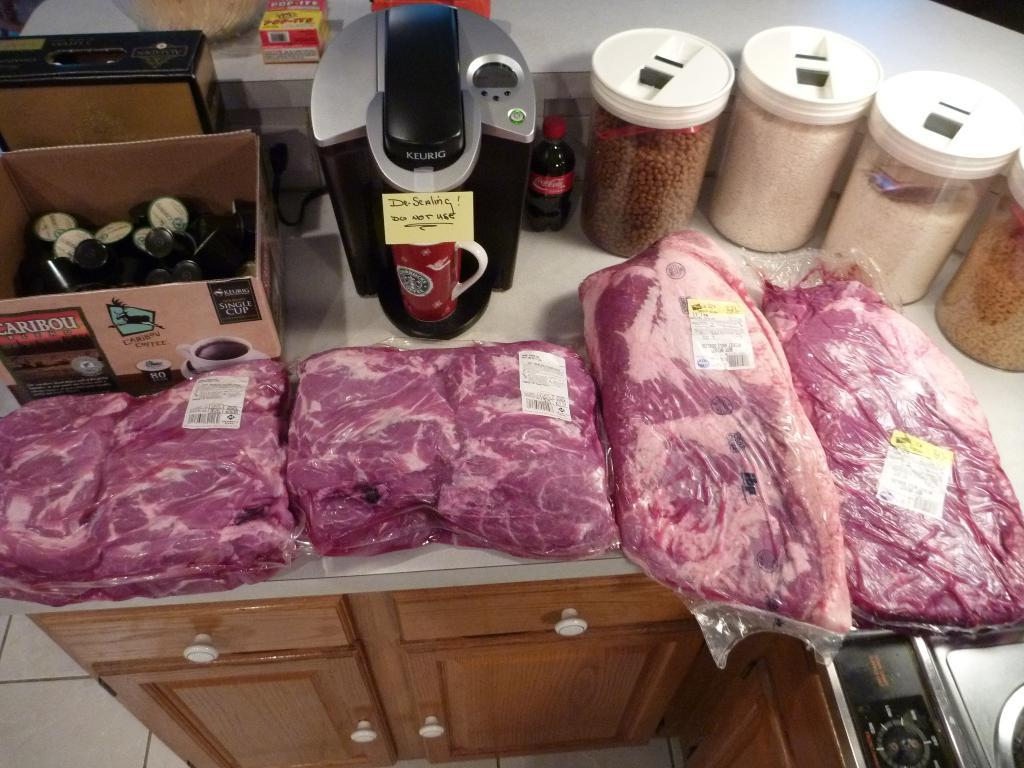Provide a one-sentence caption for the provided image. Four slabs of meat share a counter with a Keurig machine and an open box of Caribou K-pods. 